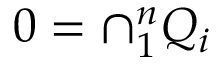<formula> <loc_0><loc_0><loc_500><loc_500>0 = \cap _ { 1 } ^ { n } Q _ { i }</formula> 